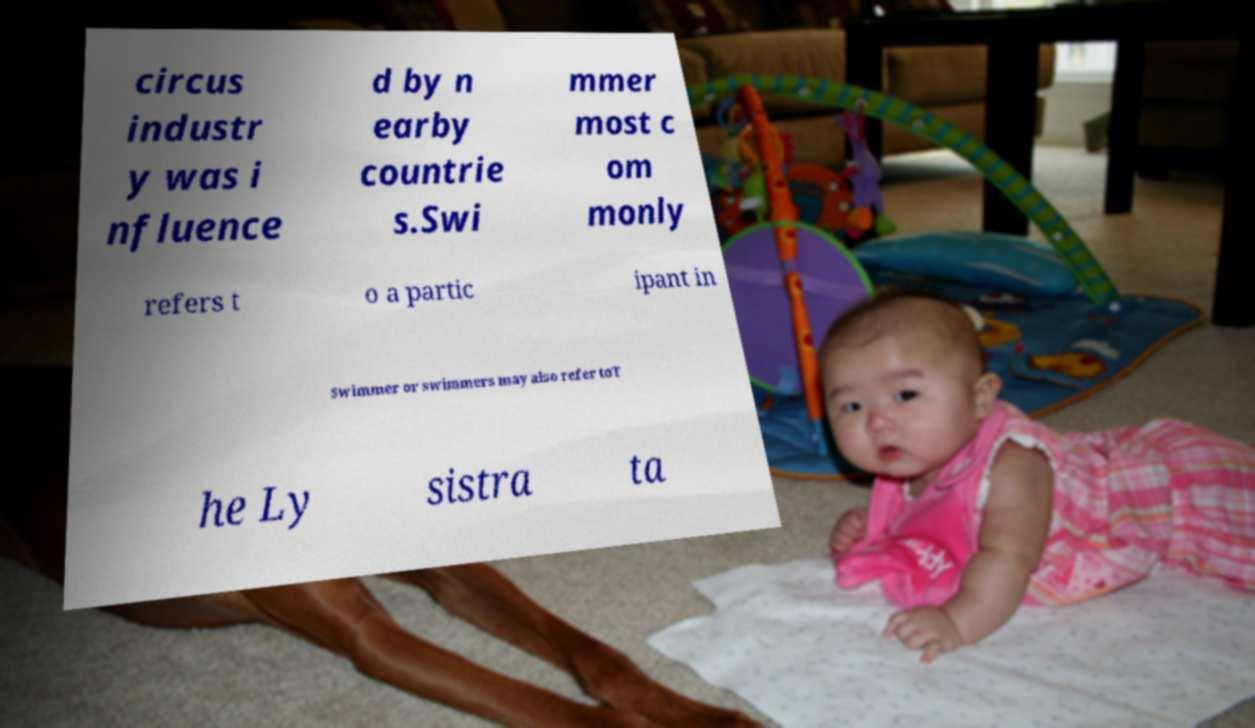Can you accurately transcribe the text from the provided image for me? circus industr y was i nfluence d by n earby countrie s.Swi mmer most c om monly refers t o a partic ipant in Swimmer or swimmers may also refer toT he Ly sistra ta 